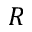Convert formula to latex. <formula><loc_0><loc_0><loc_500><loc_500>R</formula> 